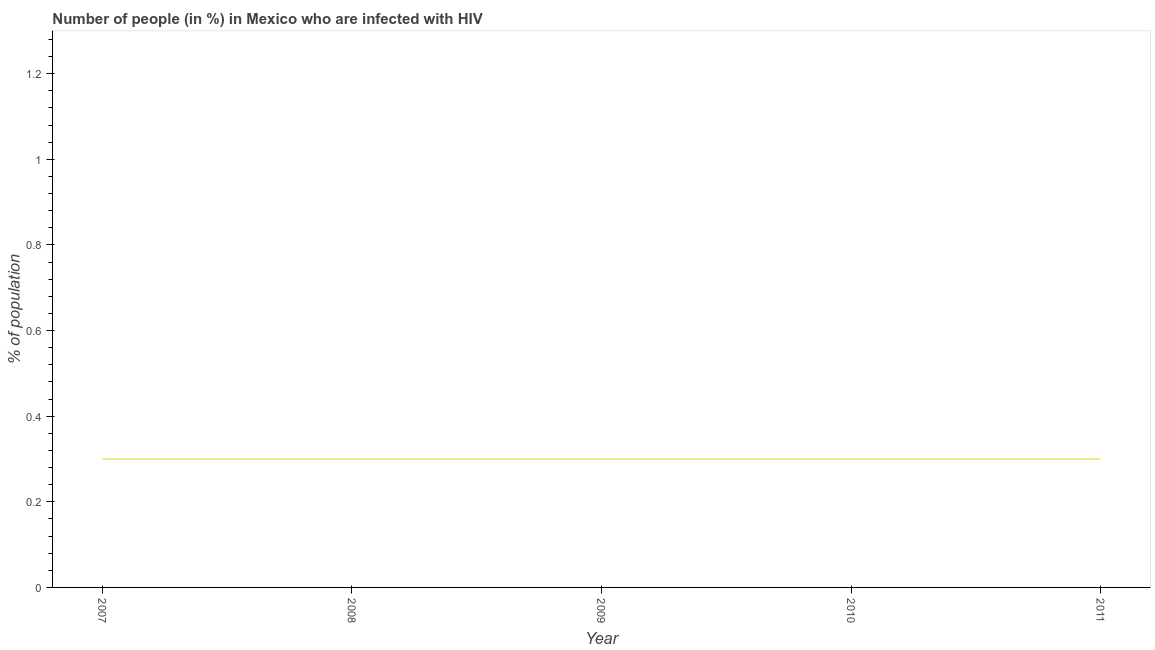What is the number of people infected with hiv in 2011?
Your answer should be compact. 0.3. Across all years, what is the maximum number of people infected with hiv?
Provide a succinct answer. 0.3. In which year was the number of people infected with hiv maximum?
Offer a terse response. 2007. What is the average number of people infected with hiv per year?
Offer a very short reply. 0.3. Do a majority of the years between 2009 and 2007 (inclusive) have number of people infected with hiv greater than 0.44 %?
Provide a succinct answer. No. What is the ratio of the number of people infected with hiv in 2007 to that in 2009?
Offer a very short reply. 1. Is the number of people infected with hiv in 2007 less than that in 2010?
Your response must be concise. No. Is the sum of the number of people infected with hiv in 2007 and 2011 greater than the maximum number of people infected with hiv across all years?
Offer a terse response. Yes. What is the difference between the highest and the lowest number of people infected with hiv?
Give a very brief answer. 0. In how many years, is the number of people infected with hiv greater than the average number of people infected with hiv taken over all years?
Make the answer very short. 0. How many years are there in the graph?
Offer a terse response. 5. What is the difference between two consecutive major ticks on the Y-axis?
Ensure brevity in your answer.  0.2. Does the graph contain any zero values?
Offer a terse response. No. Does the graph contain grids?
Your answer should be compact. No. What is the title of the graph?
Provide a succinct answer. Number of people (in %) in Mexico who are infected with HIV. What is the label or title of the X-axis?
Offer a terse response. Year. What is the label or title of the Y-axis?
Give a very brief answer. % of population. What is the % of population of 2008?
Offer a terse response. 0.3. What is the % of population of 2009?
Provide a succinct answer. 0.3. What is the % of population in 2011?
Provide a succinct answer. 0.3. What is the difference between the % of population in 2007 and 2008?
Provide a short and direct response. 0. What is the difference between the % of population in 2007 and 2009?
Offer a terse response. 0. What is the difference between the % of population in 2008 and 2009?
Offer a terse response. 0. What is the difference between the % of population in 2008 and 2010?
Offer a terse response. 0. What is the difference between the % of population in 2009 and 2010?
Keep it short and to the point. 0. What is the difference between the % of population in 2010 and 2011?
Offer a very short reply. 0. What is the ratio of the % of population in 2007 to that in 2008?
Your answer should be compact. 1. What is the ratio of the % of population in 2007 to that in 2011?
Your answer should be very brief. 1. What is the ratio of the % of population in 2008 to that in 2010?
Your answer should be very brief. 1. What is the ratio of the % of population in 2008 to that in 2011?
Offer a terse response. 1. 